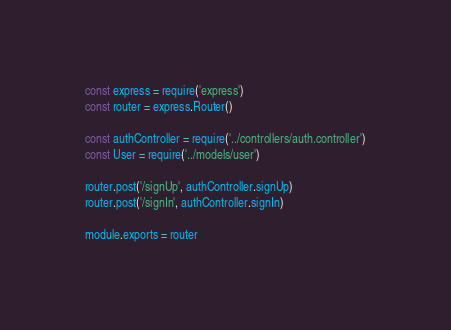<code> <loc_0><loc_0><loc_500><loc_500><_JavaScript_>const express = require('express')
const router = express.Router()

const authController = require('../controllers/auth.controller')
const User = require('../models/user')

router.post('/signUp', authController.signUp)
router.post('/signIn', authController.signIn)

module.exports = router</code> 